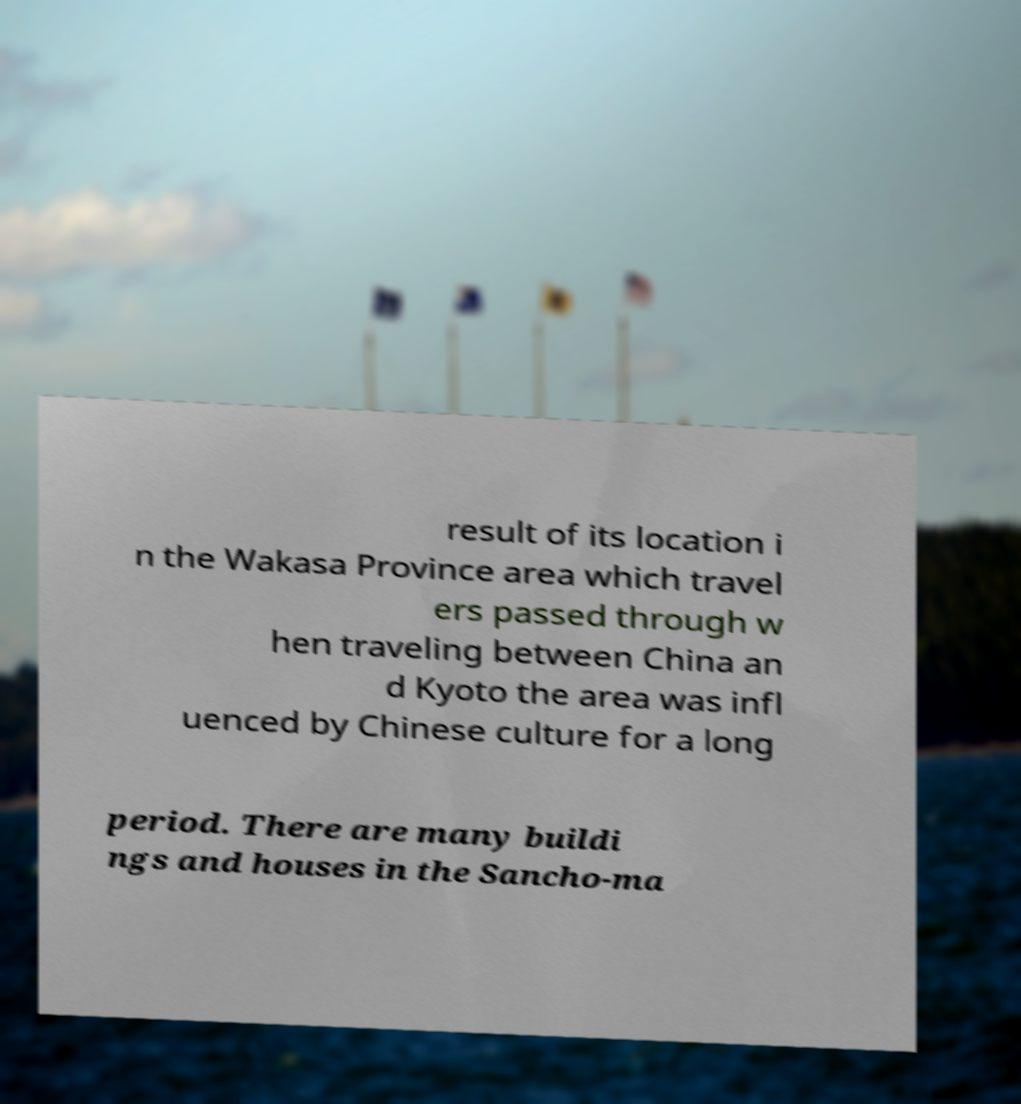Could you extract and type out the text from this image? result of its location i n the Wakasa Province area which travel ers passed through w hen traveling between China an d Kyoto the area was infl uenced by Chinese culture for a long period. There are many buildi ngs and houses in the Sancho-ma 